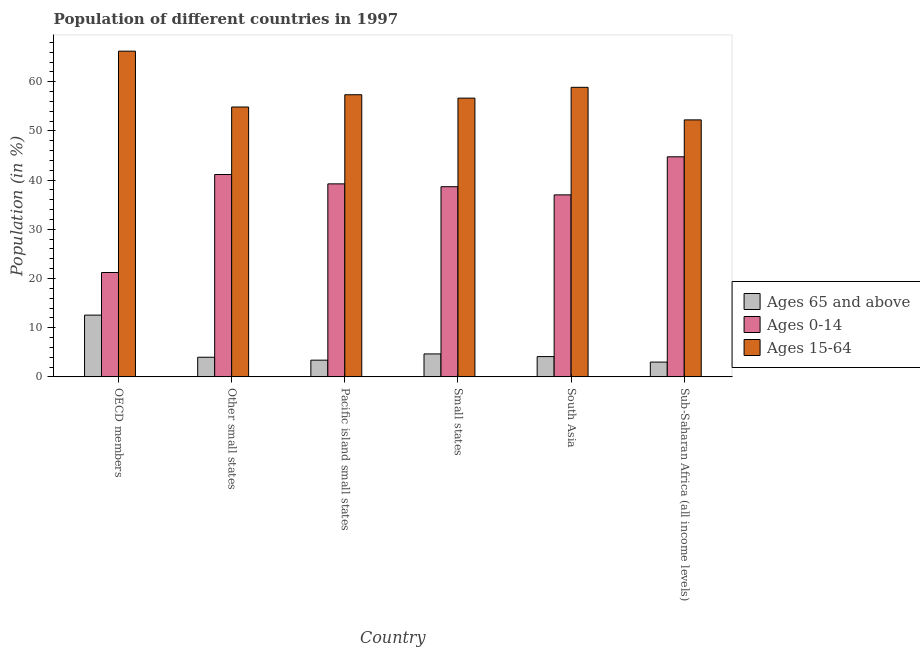How many different coloured bars are there?
Provide a succinct answer. 3. How many groups of bars are there?
Provide a short and direct response. 6. Are the number of bars per tick equal to the number of legend labels?
Give a very brief answer. Yes. Are the number of bars on each tick of the X-axis equal?
Provide a succinct answer. Yes. How many bars are there on the 3rd tick from the right?
Make the answer very short. 3. What is the label of the 4th group of bars from the left?
Make the answer very short. Small states. What is the percentage of population within the age-group of 65 and above in OECD members?
Provide a succinct answer. 12.56. Across all countries, what is the maximum percentage of population within the age-group of 65 and above?
Your answer should be compact. 12.56. Across all countries, what is the minimum percentage of population within the age-group 15-64?
Ensure brevity in your answer.  52.25. In which country was the percentage of population within the age-group 0-14 maximum?
Offer a terse response. Sub-Saharan Africa (all income levels). In which country was the percentage of population within the age-group 15-64 minimum?
Give a very brief answer. Sub-Saharan Africa (all income levels). What is the total percentage of population within the age-group 15-64 in the graph?
Keep it short and to the point. 346.24. What is the difference between the percentage of population within the age-group 0-14 in Small states and that in Sub-Saharan Africa (all income levels)?
Your answer should be compact. -6.08. What is the difference between the percentage of population within the age-group of 65 and above in Small states and the percentage of population within the age-group 15-64 in Pacific island small states?
Your response must be concise. -52.7. What is the average percentage of population within the age-group 15-64 per country?
Ensure brevity in your answer.  57.71. What is the difference between the percentage of population within the age-group of 65 and above and percentage of population within the age-group 0-14 in Sub-Saharan Africa (all income levels)?
Offer a terse response. -41.74. What is the ratio of the percentage of population within the age-group 0-14 in Pacific island small states to that in South Asia?
Your answer should be very brief. 1.06. Is the percentage of population within the age-group 15-64 in Small states less than that in Sub-Saharan Africa (all income levels)?
Offer a terse response. No. What is the difference between the highest and the second highest percentage of population within the age-group 15-64?
Offer a terse response. 7.35. What is the difference between the highest and the lowest percentage of population within the age-group of 65 and above?
Offer a terse response. 9.55. In how many countries, is the percentage of population within the age-group 0-14 greater than the average percentage of population within the age-group 0-14 taken over all countries?
Provide a short and direct response. 5. Is the sum of the percentage of population within the age-group 15-64 in Small states and South Asia greater than the maximum percentage of population within the age-group 0-14 across all countries?
Keep it short and to the point. Yes. What does the 1st bar from the left in OECD members represents?
Make the answer very short. Ages 65 and above. What does the 2nd bar from the right in Small states represents?
Your response must be concise. Ages 0-14. Is it the case that in every country, the sum of the percentage of population within the age-group of 65 and above and percentage of population within the age-group 0-14 is greater than the percentage of population within the age-group 15-64?
Your response must be concise. No. How many bars are there?
Your answer should be compact. 18. Are all the bars in the graph horizontal?
Ensure brevity in your answer.  No. Are the values on the major ticks of Y-axis written in scientific E-notation?
Make the answer very short. No. Does the graph contain grids?
Offer a very short reply. No. Where does the legend appear in the graph?
Provide a succinct answer. Center right. How many legend labels are there?
Your answer should be compact. 3. How are the legend labels stacked?
Provide a short and direct response. Vertical. What is the title of the graph?
Give a very brief answer. Population of different countries in 1997. What is the label or title of the Y-axis?
Provide a succinct answer. Population (in %). What is the Population (in %) of Ages 65 and above in OECD members?
Your response must be concise. 12.56. What is the Population (in %) of Ages 0-14 in OECD members?
Your answer should be compact. 21.22. What is the Population (in %) in Ages 15-64 in OECD members?
Your answer should be very brief. 66.22. What is the Population (in %) in Ages 65 and above in Other small states?
Your answer should be compact. 3.99. What is the Population (in %) of Ages 0-14 in Other small states?
Offer a terse response. 41.14. What is the Population (in %) of Ages 15-64 in Other small states?
Your answer should be very brief. 54.87. What is the Population (in %) of Ages 65 and above in Pacific island small states?
Ensure brevity in your answer.  3.4. What is the Population (in %) of Ages 0-14 in Pacific island small states?
Your answer should be very brief. 39.24. What is the Population (in %) in Ages 15-64 in Pacific island small states?
Your answer should be compact. 57.36. What is the Population (in %) in Ages 65 and above in Small states?
Make the answer very short. 4.66. What is the Population (in %) of Ages 0-14 in Small states?
Your response must be concise. 38.66. What is the Population (in %) in Ages 15-64 in Small states?
Offer a terse response. 56.67. What is the Population (in %) in Ages 65 and above in South Asia?
Offer a terse response. 4.13. What is the Population (in %) in Ages 0-14 in South Asia?
Offer a very short reply. 37. What is the Population (in %) of Ages 15-64 in South Asia?
Offer a terse response. 58.87. What is the Population (in %) of Ages 65 and above in Sub-Saharan Africa (all income levels)?
Offer a very short reply. 3.01. What is the Population (in %) of Ages 0-14 in Sub-Saharan Africa (all income levels)?
Your answer should be compact. 44.74. What is the Population (in %) in Ages 15-64 in Sub-Saharan Africa (all income levels)?
Offer a very short reply. 52.25. Across all countries, what is the maximum Population (in %) of Ages 65 and above?
Keep it short and to the point. 12.56. Across all countries, what is the maximum Population (in %) in Ages 0-14?
Ensure brevity in your answer.  44.74. Across all countries, what is the maximum Population (in %) in Ages 15-64?
Your answer should be very brief. 66.22. Across all countries, what is the minimum Population (in %) in Ages 65 and above?
Keep it short and to the point. 3.01. Across all countries, what is the minimum Population (in %) of Ages 0-14?
Provide a short and direct response. 21.22. Across all countries, what is the minimum Population (in %) in Ages 15-64?
Provide a short and direct response. 52.25. What is the total Population (in %) in Ages 65 and above in the graph?
Your response must be concise. 31.74. What is the total Population (in %) in Ages 0-14 in the graph?
Provide a short and direct response. 222.01. What is the total Population (in %) of Ages 15-64 in the graph?
Provide a succinct answer. 346.24. What is the difference between the Population (in %) of Ages 65 and above in OECD members and that in Other small states?
Keep it short and to the point. 8.56. What is the difference between the Population (in %) in Ages 0-14 in OECD members and that in Other small states?
Ensure brevity in your answer.  -19.92. What is the difference between the Population (in %) of Ages 15-64 in OECD members and that in Other small states?
Your response must be concise. 11.35. What is the difference between the Population (in %) in Ages 65 and above in OECD members and that in Pacific island small states?
Your answer should be very brief. 9.16. What is the difference between the Population (in %) of Ages 0-14 in OECD members and that in Pacific island small states?
Offer a very short reply. -18.02. What is the difference between the Population (in %) in Ages 15-64 in OECD members and that in Pacific island small states?
Make the answer very short. 8.86. What is the difference between the Population (in %) in Ages 65 and above in OECD members and that in Small states?
Keep it short and to the point. 7.89. What is the difference between the Population (in %) of Ages 0-14 in OECD members and that in Small states?
Ensure brevity in your answer.  -17.44. What is the difference between the Population (in %) in Ages 15-64 in OECD members and that in Small states?
Your answer should be very brief. 9.55. What is the difference between the Population (in %) in Ages 65 and above in OECD members and that in South Asia?
Keep it short and to the point. 8.43. What is the difference between the Population (in %) in Ages 0-14 in OECD members and that in South Asia?
Provide a short and direct response. -15.78. What is the difference between the Population (in %) in Ages 15-64 in OECD members and that in South Asia?
Your answer should be compact. 7.35. What is the difference between the Population (in %) in Ages 65 and above in OECD members and that in Sub-Saharan Africa (all income levels)?
Make the answer very short. 9.55. What is the difference between the Population (in %) of Ages 0-14 in OECD members and that in Sub-Saharan Africa (all income levels)?
Provide a succinct answer. -23.52. What is the difference between the Population (in %) of Ages 15-64 in OECD members and that in Sub-Saharan Africa (all income levels)?
Give a very brief answer. 13.97. What is the difference between the Population (in %) in Ages 65 and above in Other small states and that in Pacific island small states?
Offer a very short reply. 0.59. What is the difference between the Population (in %) in Ages 0-14 in Other small states and that in Pacific island small states?
Provide a short and direct response. 1.9. What is the difference between the Population (in %) in Ages 15-64 in Other small states and that in Pacific island small states?
Offer a very short reply. -2.49. What is the difference between the Population (in %) of Ages 65 and above in Other small states and that in Small states?
Offer a terse response. -0.67. What is the difference between the Population (in %) in Ages 0-14 in Other small states and that in Small states?
Offer a very short reply. 2.48. What is the difference between the Population (in %) in Ages 15-64 in Other small states and that in Small states?
Provide a succinct answer. -1.8. What is the difference between the Population (in %) of Ages 65 and above in Other small states and that in South Asia?
Your answer should be very brief. -0.13. What is the difference between the Population (in %) in Ages 0-14 in Other small states and that in South Asia?
Your answer should be compact. 4.14. What is the difference between the Population (in %) of Ages 15-64 in Other small states and that in South Asia?
Ensure brevity in your answer.  -4. What is the difference between the Population (in %) in Ages 65 and above in Other small states and that in Sub-Saharan Africa (all income levels)?
Keep it short and to the point. 0.99. What is the difference between the Population (in %) in Ages 0-14 in Other small states and that in Sub-Saharan Africa (all income levels)?
Offer a very short reply. -3.61. What is the difference between the Population (in %) of Ages 15-64 in Other small states and that in Sub-Saharan Africa (all income levels)?
Your answer should be very brief. 2.62. What is the difference between the Population (in %) in Ages 65 and above in Pacific island small states and that in Small states?
Offer a very short reply. -1.27. What is the difference between the Population (in %) in Ages 0-14 in Pacific island small states and that in Small states?
Make the answer very short. 0.58. What is the difference between the Population (in %) of Ages 15-64 in Pacific island small states and that in Small states?
Make the answer very short. 0.69. What is the difference between the Population (in %) in Ages 65 and above in Pacific island small states and that in South Asia?
Provide a short and direct response. -0.73. What is the difference between the Population (in %) in Ages 0-14 in Pacific island small states and that in South Asia?
Offer a very short reply. 2.24. What is the difference between the Population (in %) of Ages 15-64 in Pacific island small states and that in South Asia?
Your answer should be compact. -1.51. What is the difference between the Population (in %) of Ages 65 and above in Pacific island small states and that in Sub-Saharan Africa (all income levels)?
Ensure brevity in your answer.  0.39. What is the difference between the Population (in %) in Ages 0-14 in Pacific island small states and that in Sub-Saharan Africa (all income levels)?
Provide a succinct answer. -5.5. What is the difference between the Population (in %) in Ages 15-64 in Pacific island small states and that in Sub-Saharan Africa (all income levels)?
Give a very brief answer. 5.11. What is the difference between the Population (in %) in Ages 65 and above in Small states and that in South Asia?
Provide a succinct answer. 0.54. What is the difference between the Population (in %) of Ages 0-14 in Small states and that in South Asia?
Your answer should be very brief. 1.66. What is the difference between the Population (in %) of Ages 15-64 in Small states and that in South Asia?
Ensure brevity in your answer.  -2.2. What is the difference between the Population (in %) in Ages 65 and above in Small states and that in Sub-Saharan Africa (all income levels)?
Provide a short and direct response. 1.66. What is the difference between the Population (in %) in Ages 0-14 in Small states and that in Sub-Saharan Africa (all income levels)?
Provide a succinct answer. -6.08. What is the difference between the Population (in %) in Ages 15-64 in Small states and that in Sub-Saharan Africa (all income levels)?
Give a very brief answer. 4.42. What is the difference between the Population (in %) of Ages 65 and above in South Asia and that in Sub-Saharan Africa (all income levels)?
Ensure brevity in your answer.  1.12. What is the difference between the Population (in %) of Ages 0-14 in South Asia and that in Sub-Saharan Africa (all income levels)?
Provide a short and direct response. -7.74. What is the difference between the Population (in %) in Ages 15-64 in South Asia and that in Sub-Saharan Africa (all income levels)?
Give a very brief answer. 6.62. What is the difference between the Population (in %) of Ages 65 and above in OECD members and the Population (in %) of Ages 0-14 in Other small states?
Keep it short and to the point. -28.58. What is the difference between the Population (in %) in Ages 65 and above in OECD members and the Population (in %) in Ages 15-64 in Other small states?
Your answer should be very brief. -42.31. What is the difference between the Population (in %) of Ages 0-14 in OECD members and the Population (in %) of Ages 15-64 in Other small states?
Ensure brevity in your answer.  -33.65. What is the difference between the Population (in %) in Ages 65 and above in OECD members and the Population (in %) in Ages 0-14 in Pacific island small states?
Provide a short and direct response. -26.68. What is the difference between the Population (in %) in Ages 65 and above in OECD members and the Population (in %) in Ages 15-64 in Pacific island small states?
Keep it short and to the point. -44.8. What is the difference between the Population (in %) in Ages 0-14 in OECD members and the Population (in %) in Ages 15-64 in Pacific island small states?
Ensure brevity in your answer.  -36.14. What is the difference between the Population (in %) of Ages 65 and above in OECD members and the Population (in %) of Ages 0-14 in Small states?
Keep it short and to the point. -26.11. What is the difference between the Population (in %) in Ages 65 and above in OECD members and the Population (in %) in Ages 15-64 in Small states?
Give a very brief answer. -44.12. What is the difference between the Population (in %) of Ages 0-14 in OECD members and the Population (in %) of Ages 15-64 in Small states?
Give a very brief answer. -35.45. What is the difference between the Population (in %) of Ages 65 and above in OECD members and the Population (in %) of Ages 0-14 in South Asia?
Your answer should be compact. -24.45. What is the difference between the Population (in %) in Ages 65 and above in OECD members and the Population (in %) in Ages 15-64 in South Asia?
Make the answer very short. -46.31. What is the difference between the Population (in %) of Ages 0-14 in OECD members and the Population (in %) of Ages 15-64 in South Asia?
Make the answer very short. -37.65. What is the difference between the Population (in %) of Ages 65 and above in OECD members and the Population (in %) of Ages 0-14 in Sub-Saharan Africa (all income levels)?
Your answer should be compact. -32.19. What is the difference between the Population (in %) of Ages 65 and above in OECD members and the Population (in %) of Ages 15-64 in Sub-Saharan Africa (all income levels)?
Provide a short and direct response. -39.69. What is the difference between the Population (in %) of Ages 0-14 in OECD members and the Population (in %) of Ages 15-64 in Sub-Saharan Africa (all income levels)?
Ensure brevity in your answer.  -31.03. What is the difference between the Population (in %) of Ages 65 and above in Other small states and the Population (in %) of Ages 0-14 in Pacific island small states?
Your response must be concise. -35.25. What is the difference between the Population (in %) in Ages 65 and above in Other small states and the Population (in %) in Ages 15-64 in Pacific island small states?
Keep it short and to the point. -53.37. What is the difference between the Population (in %) of Ages 0-14 in Other small states and the Population (in %) of Ages 15-64 in Pacific island small states?
Your response must be concise. -16.22. What is the difference between the Population (in %) of Ages 65 and above in Other small states and the Population (in %) of Ages 0-14 in Small states?
Keep it short and to the point. -34.67. What is the difference between the Population (in %) of Ages 65 and above in Other small states and the Population (in %) of Ages 15-64 in Small states?
Make the answer very short. -52.68. What is the difference between the Population (in %) of Ages 0-14 in Other small states and the Population (in %) of Ages 15-64 in Small states?
Ensure brevity in your answer.  -15.53. What is the difference between the Population (in %) of Ages 65 and above in Other small states and the Population (in %) of Ages 0-14 in South Asia?
Offer a very short reply. -33.01. What is the difference between the Population (in %) of Ages 65 and above in Other small states and the Population (in %) of Ages 15-64 in South Asia?
Your answer should be very brief. -54.88. What is the difference between the Population (in %) in Ages 0-14 in Other small states and the Population (in %) in Ages 15-64 in South Asia?
Provide a succinct answer. -17.73. What is the difference between the Population (in %) of Ages 65 and above in Other small states and the Population (in %) of Ages 0-14 in Sub-Saharan Africa (all income levels)?
Give a very brief answer. -40.75. What is the difference between the Population (in %) of Ages 65 and above in Other small states and the Population (in %) of Ages 15-64 in Sub-Saharan Africa (all income levels)?
Your answer should be very brief. -48.26. What is the difference between the Population (in %) in Ages 0-14 in Other small states and the Population (in %) in Ages 15-64 in Sub-Saharan Africa (all income levels)?
Your response must be concise. -11.11. What is the difference between the Population (in %) in Ages 65 and above in Pacific island small states and the Population (in %) in Ages 0-14 in Small states?
Make the answer very short. -35.27. What is the difference between the Population (in %) of Ages 65 and above in Pacific island small states and the Population (in %) of Ages 15-64 in Small states?
Your response must be concise. -53.27. What is the difference between the Population (in %) of Ages 0-14 in Pacific island small states and the Population (in %) of Ages 15-64 in Small states?
Ensure brevity in your answer.  -17.43. What is the difference between the Population (in %) of Ages 65 and above in Pacific island small states and the Population (in %) of Ages 0-14 in South Asia?
Your answer should be compact. -33.61. What is the difference between the Population (in %) in Ages 65 and above in Pacific island small states and the Population (in %) in Ages 15-64 in South Asia?
Your answer should be compact. -55.47. What is the difference between the Population (in %) of Ages 0-14 in Pacific island small states and the Population (in %) of Ages 15-64 in South Asia?
Your answer should be very brief. -19.63. What is the difference between the Population (in %) in Ages 65 and above in Pacific island small states and the Population (in %) in Ages 0-14 in Sub-Saharan Africa (all income levels)?
Your response must be concise. -41.35. What is the difference between the Population (in %) of Ages 65 and above in Pacific island small states and the Population (in %) of Ages 15-64 in Sub-Saharan Africa (all income levels)?
Your answer should be very brief. -48.85. What is the difference between the Population (in %) of Ages 0-14 in Pacific island small states and the Population (in %) of Ages 15-64 in Sub-Saharan Africa (all income levels)?
Ensure brevity in your answer.  -13.01. What is the difference between the Population (in %) in Ages 65 and above in Small states and the Population (in %) in Ages 0-14 in South Asia?
Ensure brevity in your answer.  -32.34. What is the difference between the Population (in %) of Ages 65 and above in Small states and the Population (in %) of Ages 15-64 in South Asia?
Make the answer very short. -54.21. What is the difference between the Population (in %) in Ages 0-14 in Small states and the Population (in %) in Ages 15-64 in South Asia?
Provide a short and direct response. -20.21. What is the difference between the Population (in %) in Ages 65 and above in Small states and the Population (in %) in Ages 0-14 in Sub-Saharan Africa (all income levels)?
Your answer should be very brief. -40.08. What is the difference between the Population (in %) in Ages 65 and above in Small states and the Population (in %) in Ages 15-64 in Sub-Saharan Africa (all income levels)?
Provide a succinct answer. -47.59. What is the difference between the Population (in %) of Ages 0-14 in Small states and the Population (in %) of Ages 15-64 in Sub-Saharan Africa (all income levels)?
Offer a very short reply. -13.58. What is the difference between the Population (in %) of Ages 65 and above in South Asia and the Population (in %) of Ages 0-14 in Sub-Saharan Africa (all income levels)?
Offer a terse response. -40.62. What is the difference between the Population (in %) in Ages 65 and above in South Asia and the Population (in %) in Ages 15-64 in Sub-Saharan Africa (all income levels)?
Your answer should be compact. -48.12. What is the difference between the Population (in %) of Ages 0-14 in South Asia and the Population (in %) of Ages 15-64 in Sub-Saharan Africa (all income levels)?
Make the answer very short. -15.25. What is the average Population (in %) of Ages 65 and above per country?
Keep it short and to the point. 5.29. What is the average Population (in %) in Ages 0-14 per country?
Your answer should be very brief. 37. What is the average Population (in %) of Ages 15-64 per country?
Make the answer very short. 57.71. What is the difference between the Population (in %) of Ages 65 and above and Population (in %) of Ages 0-14 in OECD members?
Make the answer very short. -8.66. What is the difference between the Population (in %) in Ages 65 and above and Population (in %) in Ages 15-64 in OECD members?
Provide a short and direct response. -53.67. What is the difference between the Population (in %) in Ages 0-14 and Population (in %) in Ages 15-64 in OECD members?
Provide a succinct answer. -45. What is the difference between the Population (in %) in Ages 65 and above and Population (in %) in Ages 0-14 in Other small states?
Make the answer very short. -37.15. What is the difference between the Population (in %) in Ages 65 and above and Population (in %) in Ages 15-64 in Other small states?
Your answer should be compact. -50.88. What is the difference between the Population (in %) in Ages 0-14 and Population (in %) in Ages 15-64 in Other small states?
Provide a succinct answer. -13.73. What is the difference between the Population (in %) of Ages 65 and above and Population (in %) of Ages 0-14 in Pacific island small states?
Provide a short and direct response. -35.84. What is the difference between the Population (in %) in Ages 65 and above and Population (in %) in Ages 15-64 in Pacific island small states?
Offer a terse response. -53.96. What is the difference between the Population (in %) of Ages 0-14 and Population (in %) of Ages 15-64 in Pacific island small states?
Keep it short and to the point. -18.12. What is the difference between the Population (in %) of Ages 65 and above and Population (in %) of Ages 0-14 in Small states?
Make the answer very short. -34. What is the difference between the Population (in %) in Ages 65 and above and Population (in %) in Ages 15-64 in Small states?
Make the answer very short. -52.01. What is the difference between the Population (in %) of Ages 0-14 and Population (in %) of Ages 15-64 in Small states?
Give a very brief answer. -18.01. What is the difference between the Population (in %) of Ages 65 and above and Population (in %) of Ages 0-14 in South Asia?
Make the answer very short. -32.88. What is the difference between the Population (in %) of Ages 65 and above and Population (in %) of Ages 15-64 in South Asia?
Your answer should be very brief. -54.74. What is the difference between the Population (in %) of Ages 0-14 and Population (in %) of Ages 15-64 in South Asia?
Your answer should be compact. -21.87. What is the difference between the Population (in %) of Ages 65 and above and Population (in %) of Ages 0-14 in Sub-Saharan Africa (all income levels)?
Give a very brief answer. -41.74. What is the difference between the Population (in %) in Ages 65 and above and Population (in %) in Ages 15-64 in Sub-Saharan Africa (all income levels)?
Your answer should be compact. -49.24. What is the difference between the Population (in %) of Ages 0-14 and Population (in %) of Ages 15-64 in Sub-Saharan Africa (all income levels)?
Keep it short and to the point. -7.5. What is the ratio of the Population (in %) of Ages 65 and above in OECD members to that in Other small states?
Ensure brevity in your answer.  3.15. What is the ratio of the Population (in %) in Ages 0-14 in OECD members to that in Other small states?
Your response must be concise. 0.52. What is the ratio of the Population (in %) of Ages 15-64 in OECD members to that in Other small states?
Give a very brief answer. 1.21. What is the ratio of the Population (in %) of Ages 65 and above in OECD members to that in Pacific island small states?
Provide a succinct answer. 3.7. What is the ratio of the Population (in %) of Ages 0-14 in OECD members to that in Pacific island small states?
Your answer should be compact. 0.54. What is the ratio of the Population (in %) of Ages 15-64 in OECD members to that in Pacific island small states?
Your response must be concise. 1.15. What is the ratio of the Population (in %) of Ages 65 and above in OECD members to that in Small states?
Offer a terse response. 2.69. What is the ratio of the Population (in %) of Ages 0-14 in OECD members to that in Small states?
Your answer should be compact. 0.55. What is the ratio of the Population (in %) of Ages 15-64 in OECD members to that in Small states?
Your answer should be very brief. 1.17. What is the ratio of the Population (in %) of Ages 65 and above in OECD members to that in South Asia?
Offer a terse response. 3.04. What is the ratio of the Population (in %) of Ages 0-14 in OECD members to that in South Asia?
Offer a terse response. 0.57. What is the ratio of the Population (in %) of Ages 15-64 in OECD members to that in South Asia?
Make the answer very short. 1.12. What is the ratio of the Population (in %) of Ages 65 and above in OECD members to that in Sub-Saharan Africa (all income levels)?
Ensure brevity in your answer.  4.18. What is the ratio of the Population (in %) in Ages 0-14 in OECD members to that in Sub-Saharan Africa (all income levels)?
Make the answer very short. 0.47. What is the ratio of the Population (in %) in Ages 15-64 in OECD members to that in Sub-Saharan Africa (all income levels)?
Provide a succinct answer. 1.27. What is the ratio of the Population (in %) in Ages 65 and above in Other small states to that in Pacific island small states?
Give a very brief answer. 1.18. What is the ratio of the Population (in %) in Ages 0-14 in Other small states to that in Pacific island small states?
Ensure brevity in your answer.  1.05. What is the ratio of the Population (in %) of Ages 15-64 in Other small states to that in Pacific island small states?
Provide a short and direct response. 0.96. What is the ratio of the Population (in %) of Ages 65 and above in Other small states to that in Small states?
Keep it short and to the point. 0.86. What is the ratio of the Population (in %) in Ages 0-14 in Other small states to that in Small states?
Provide a succinct answer. 1.06. What is the ratio of the Population (in %) in Ages 15-64 in Other small states to that in Small states?
Your answer should be compact. 0.97. What is the ratio of the Population (in %) in Ages 65 and above in Other small states to that in South Asia?
Offer a very short reply. 0.97. What is the ratio of the Population (in %) in Ages 0-14 in Other small states to that in South Asia?
Offer a terse response. 1.11. What is the ratio of the Population (in %) of Ages 15-64 in Other small states to that in South Asia?
Your answer should be very brief. 0.93. What is the ratio of the Population (in %) in Ages 65 and above in Other small states to that in Sub-Saharan Africa (all income levels)?
Your response must be concise. 1.33. What is the ratio of the Population (in %) of Ages 0-14 in Other small states to that in Sub-Saharan Africa (all income levels)?
Make the answer very short. 0.92. What is the ratio of the Population (in %) in Ages 15-64 in Other small states to that in Sub-Saharan Africa (all income levels)?
Ensure brevity in your answer.  1.05. What is the ratio of the Population (in %) in Ages 65 and above in Pacific island small states to that in Small states?
Keep it short and to the point. 0.73. What is the ratio of the Population (in %) in Ages 0-14 in Pacific island small states to that in Small states?
Offer a terse response. 1.01. What is the ratio of the Population (in %) of Ages 15-64 in Pacific island small states to that in Small states?
Ensure brevity in your answer.  1.01. What is the ratio of the Population (in %) in Ages 65 and above in Pacific island small states to that in South Asia?
Keep it short and to the point. 0.82. What is the ratio of the Population (in %) of Ages 0-14 in Pacific island small states to that in South Asia?
Provide a succinct answer. 1.06. What is the ratio of the Population (in %) of Ages 15-64 in Pacific island small states to that in South Asia?
Your answer should be very brief. 0.97. What is the ratio of the Population (in %) of Ages 65 and above in Pacific island small states to that in Sub-Saharan Africa (all income levels)?
Offer a terse response. 1.13. What is the ratio of the Population (in %) in Ages 0-14 in Pacific island small states to that in Sub-Saharan Africa (all income levels)?
Your answer should be very brief. 0.88. What is the ratio of the Population (in %) in Ages 15-64 in Pacific island small states to that in Sub-Saharan Africa (all income levels)?
Offer a terse response. 1.1. What is the ratio of the Population (in %) in Ages 65 and above in Small states to that in South Asia?
Your answer should be very brief. 1.13. What is the ratio of the Population (in %) in Ages 0-14 in Small states to that in South Asia?
Provide a succinct answer. 1.04. What is the ratio of the Population (in %) in Ages 15-64 in Small states to that in South Asia?
Offer a terse response. 0.96. What is the ratio of the Population (in %) of Ages 65 and above in Small states to that in Sub-Saharan Africa (all income levels)?
Your answer should be very brief. 1.55. What is the ratio of the Population (in %) in Ages 0-14 in Small states to that in Sub-Saharan Africa (all income levels)?
Offer a very short reply. 0.86. What is the ratio of the Population (in %) of Ages 15-64 in Small states to that in Sub-Saharan Africa (all income levels)?
Offer a very short reply. 1.08. What is the ratio of the Population (in %) in Ages 65 and above in South Asia to that in Sub-Saharan Africa (all income levels)?
Offer a very short reply. 1.37. What is the ratio of the Population (in %) of Ages 0-14 in South Asia to that in Sub-Saharan Africa (all income levels)?
Ensure brevity in your answer.  0.83. What is the ratio of the Population (in %) in Ages 15-64 in South Asia to that in Sub-Saharan Africa (all income levels)?
Your answer should be compact. 1.13. What is the difference between the highest and the second highest Population (in %) of Ages 65 and above?
Offer a terse response. 7.89. What is the difference between the highest and the second highest Population (in %) in Ages 0-14?
Your answer should be compact. 3.61. What is the difference between the highest and the second highest Population (in %) in Ages 15-64?
Keep it short and to the point. 7.35. What is the difference between the highest and the lowest Population (in %) in Ages 65 and above?
Ensure brevity in your answer.  9.55. What is the difference between the highest and the lowest Population (in %) in Ages 0-14?
Provide a short and direct response. 23.52. What is the difference between the highest and the lowest Population (in %) in Ages 15-64?
Give a very brief answer. 13.97. 